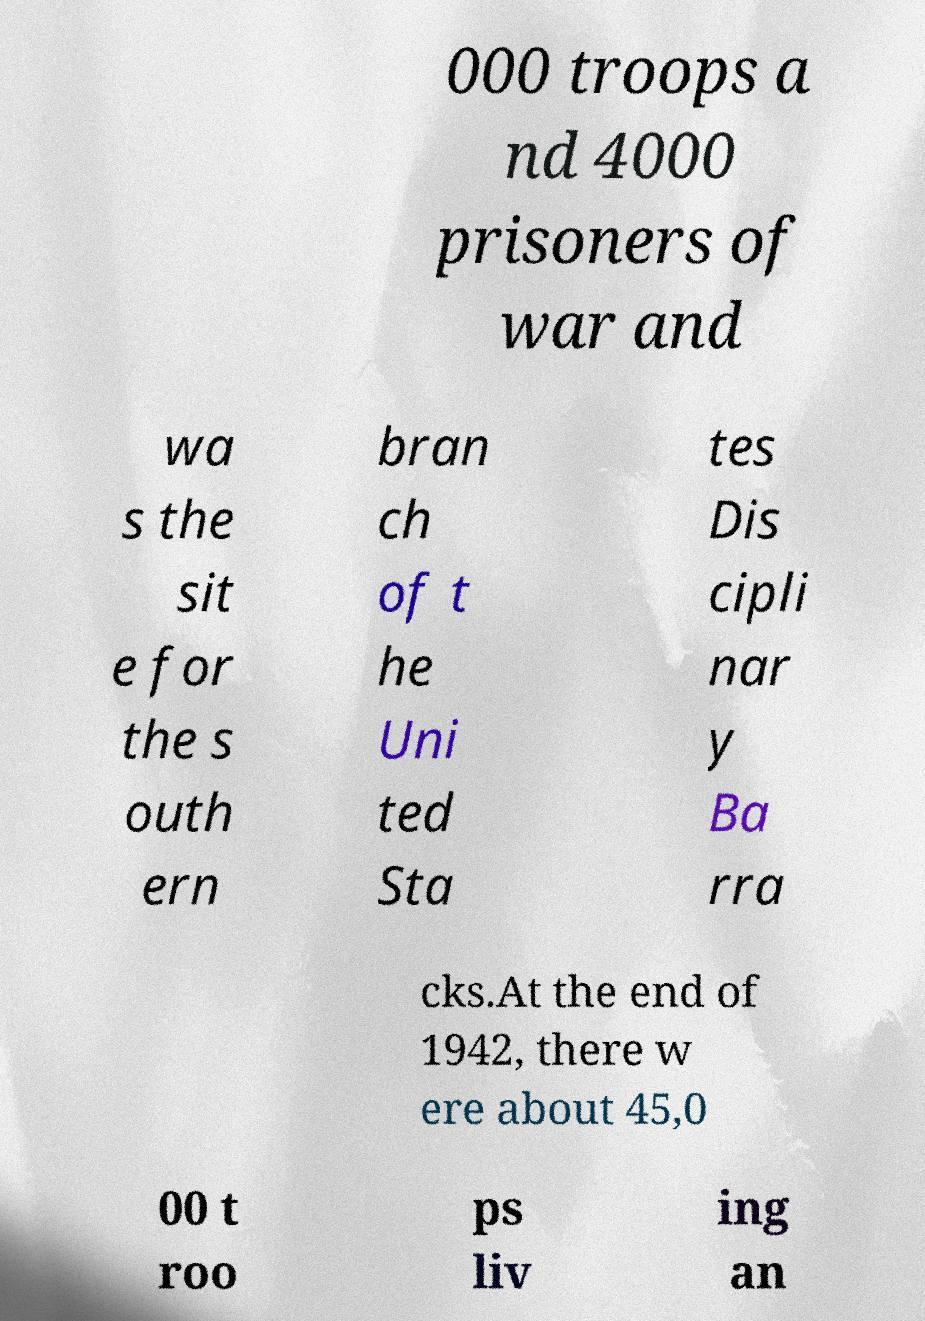There's text embedded in this image that I need extracted. Can you transcribe it verbatim? 000 troops a nd 4000 prisoners of war and wa s the sit e for the s outh ern bran ch of t he Uni ted Sta tes Dis cipli nar y Ba rra cks.At the end of 1942, there w ere about 45,0 00 t roo ps liv ing an 